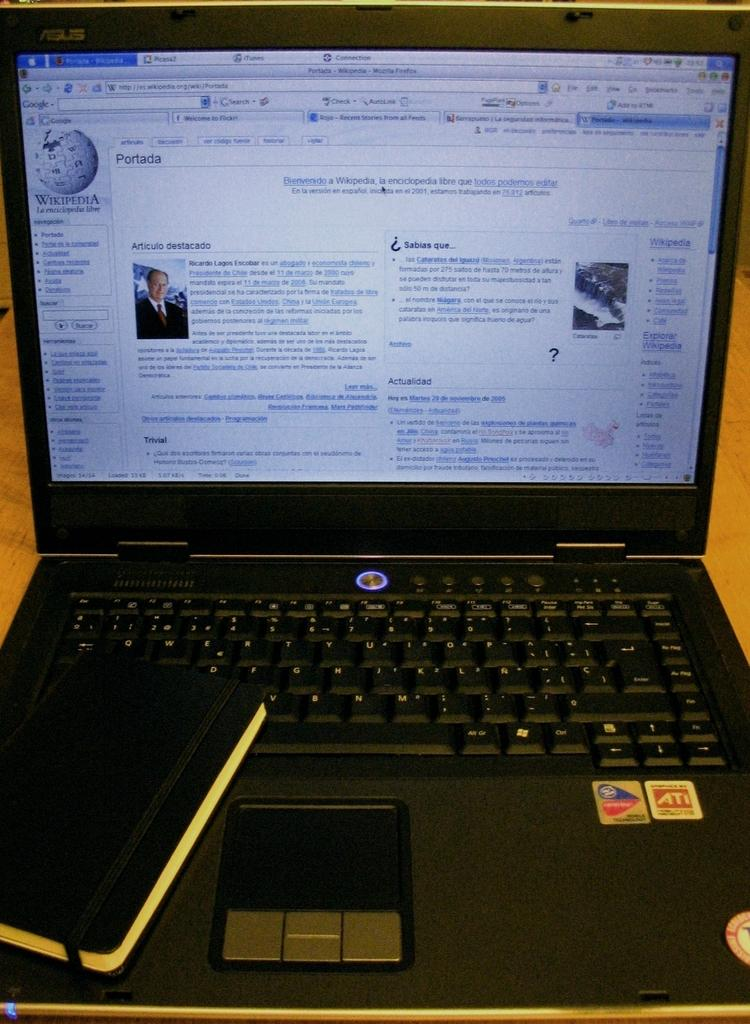What electronic device is present in the image? There is a laptop in the image. Where is the laptop located? The laptop is on a table. What is the color of the laptop? The laptop is black in color. What can be seen on the laptop screen? There is text visible on the laptop screen. How does the fog affect the laptop's performance in the image? There is no fog present in the image, so it cannot affect the laptop's performance. 